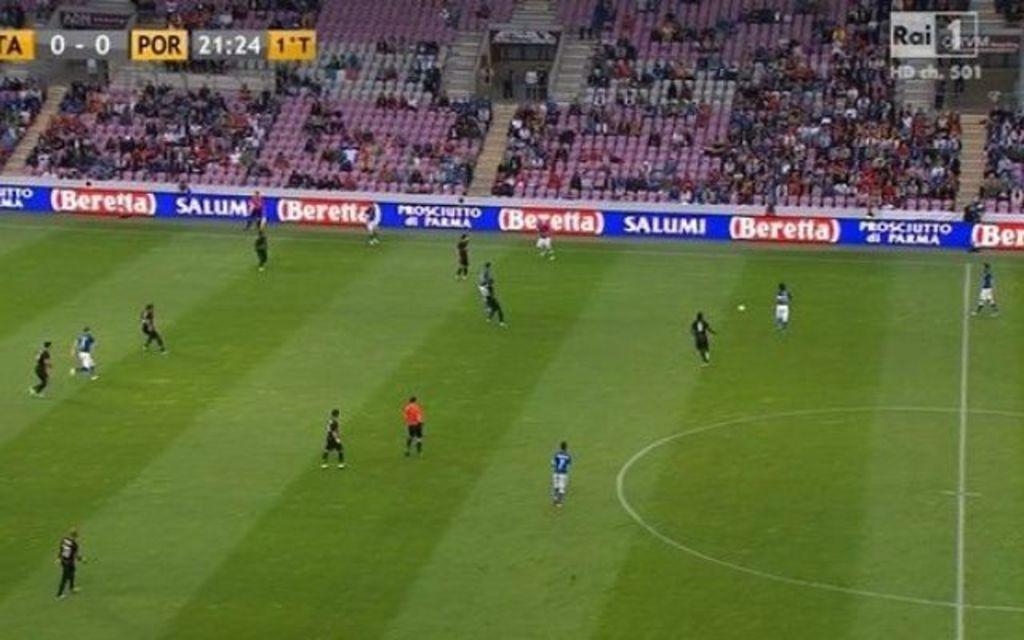How much time is in the game?
Ensure brevity in your answer.  21:24. Who is the game sponsor?
Offer a terse response. Beretta. 